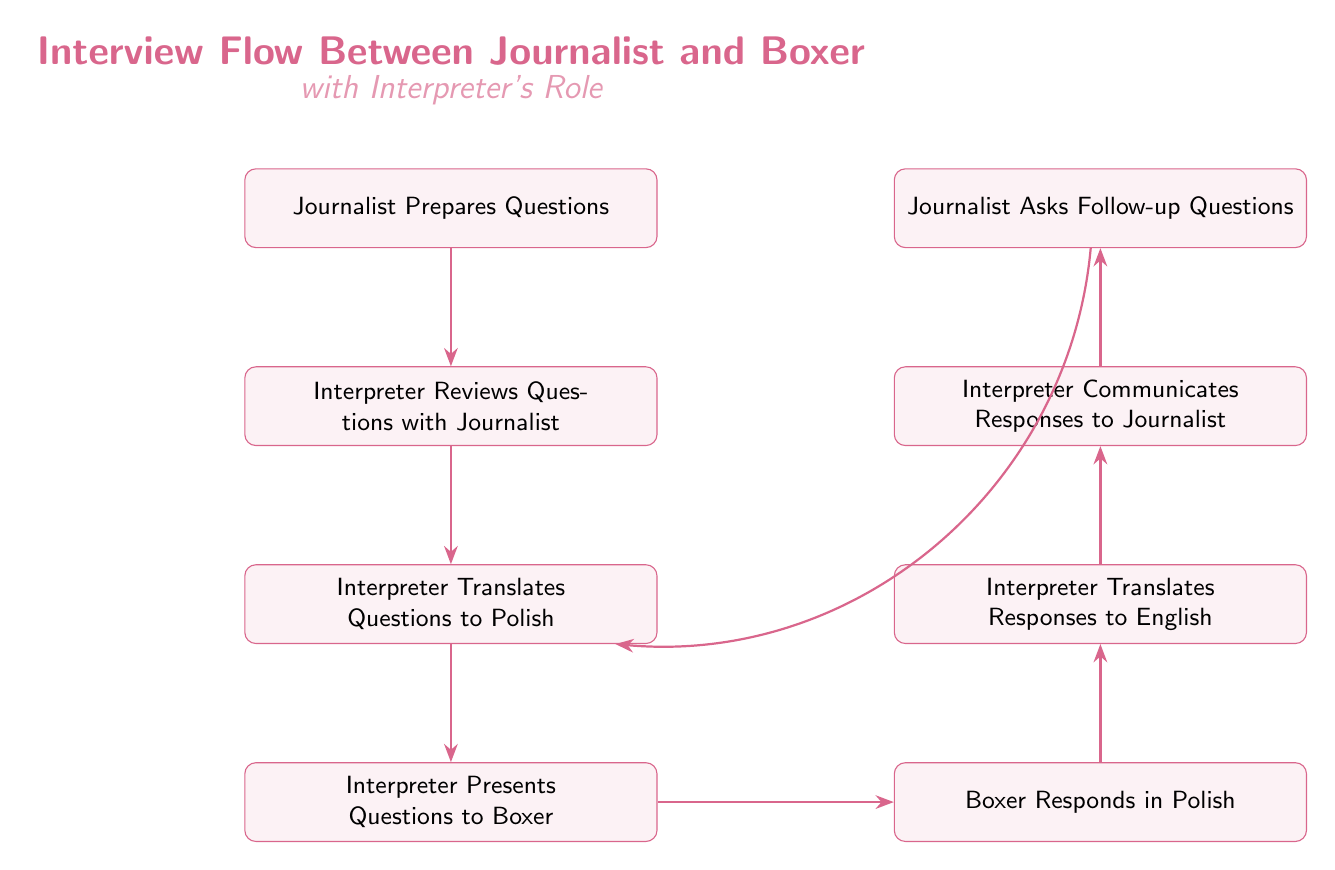What is the first action in the interview flow? The first action in the flow is identified in the first node, which states that the "Journalist Prepares Questions." Therefore, it is the starting point of the flow chart.
Answer: Journalist Prepares Questions How many nodes are there in the diagram? Counting all the distinct activities or actions represented in the diagram, we see there are 8 nodes present overall.
Answer: 8 What role does the interpreter play after the journalist prepares questions? The flow indicates that after the journalist prepares questions, the next role is for the "Interpreter Reviews Questions with Journalist," making this their immediate task in the process.
Answer: Interpreter Reviews Questions with Journalist What does the boxer do in response to the interpreter's presentation of questions? The edge leads from "Interpreter Presents Questions to Boxer" to "Boxer Responds in Polish," indicating the boxer responds after being presented with the questions.
Answer: Boxer Responds in Polish What happens after the boxer responds in Polish? Following the boxer's response, the diagram shows that the next step is for the "Interpreter Translates Responses to English," which is the action taken after receiving the boxer's response.
Answer: Interpreter Translates Responses to English How does the journalist get the boxer's responses? The flow leads from "Interpreter Communicates Responses to Journalist," indicating that the journalist receives the responses through the interpreter's communication.
Answer: Interpreter Communicates Responses to Journalist How many edges connect the nodes in the diagram? By examining the edges, we note that there are 7 connections shown between the nodes, representing the flow of communication and process steps.
Answer: 7 What action allows the journalist to ask follow-up questions? The diagram shows that after receiving responses, the "Journalist Asks Follow-up Questions" is the next step, making it the action that allows follow-ups based on the prior information.
Answer: Journalist Asks Follow-up Questions What is the last task performed in this flow? The last task in the flow is indicated by the final node which states "Journalist Asks Follow-up Questions." Therefore, this marks the end of the primary sequence in the diagram.
Answer: Journalist Asks Follow-up Questions 